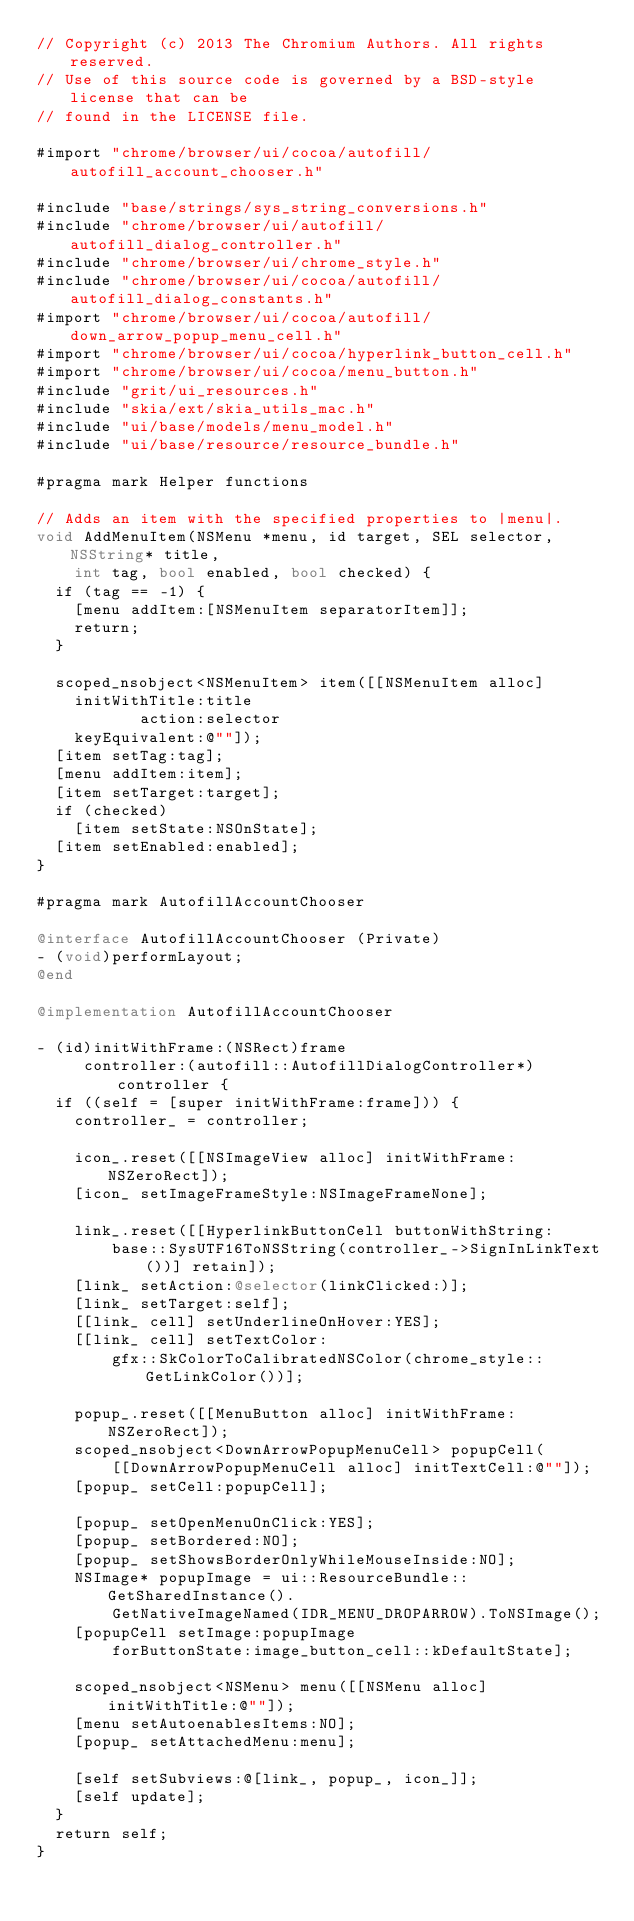<code> <loc_0><loc_0><loc_500><loc_500><_ObjectiveC_>// Copyright (c) 2013 The Chromium Authors. All rights reserved.
// Use of this source code is governed by a BSD-style license that can be
// found in the LICENSE file.

#import "chrome/browser/ui/cocoa/autofill/autofill_account_chooser.h"

#include "base/strings/sys_string_conversions.h"
#include "chrome/browser/ui/autofill/autofill_dialog_controller.h"
#include "chrome/browser/ui/chrome_style.h"
#include "chrome/browser/ui/cocoa/autofill/autofill_dialog_constants.h"
#import "chrome/browser/ui/cocoa/autofill/down_arrow_popup_menu_cell.h"
#import "chrome/browser/ui/cocoa/hyperlink_button_cell.h"
#import "chrome/browser/ui/cocoa/menu_button.h"
#include "grit/ui_resources.h"
#include "skia/ext/skia_utils_mac.h"
#include "ui/base/models/menu_model.h"
#include "ui/base/resource/resource_bundle.h"

#pragma mark Helper functions

// Adds an item with the specified properties to |menu|.
void AddMenuItem(NSMenu *menu, id target, SEL selector, NSString* title,
    int tag, bool enabled, bool checked) {
  if (tag == -1) {
    [menu addItem:[NSMenuItem separatorItem]];
    return;
  }

  scoped_nsobject<NSMenuItem> item([[NSMenuItem alloc]
    initWithTitle:title
           action:selector
    keyEquivalent:@""]);
  [item setTag:tag];
  [menu addItem:item];
  [item setTarget:target];
  if (checked)
    [item setState:NSOnState];
  [item setEnabled:enabled];
}

#pragma mark AutofillAccountChooser

@interface AutofillAccountChooser (Private)
- (void)performLayout;
@end

@implementation AutofillAccountChooser

- (id)initWithFrame:(NSRect)frame
     controller:(autofill::AutofillDialogController*)controller {
  if ((self = [super initWithFrame:frame])) {
    controller_ = controller;

    icon_.reset([[NSImageView alloc] initWithFrame:NSZeroRect]);
    [icon_ setImageFrameStyle:NSImageFrameNone];

    link_.reset([[HyperlinkButtonCell buttonWithString:
        base::SysUTF16ToNSString(controller_->SignInLinkText())] retain]);
    [link_ setAction:@selector(linkClicked:)];
    [link_ setTarget:self];
    [[link_ cell] setUnderlineOnHover:YES];
    [[link_ cell] setTextColor:
        gfx::SkColorToCalibratedNSColor(chrome_style::GetLinkColor())];

    popup_.reset([[MenuButton alloc] initWithFrame:NSZeroRect]);
    scoped_nsobject<DownArrowPopupMenuCell> popupCell(
        [[DownArrowPopupMenuCell alloc] initTextCell:@""]);
    [popup_ setCell:popupCell];

    [popup_ setOpenMenuOnClick:YES];
    [popup_ setBordered:NO];
    [popup_ setShowsBorderOnlyWhileMouseInside:NO];
    NSImage* popupImage = ui::ResourceBundle::GetSharedInstance().
        GetNativeImageNamed(IDR_MENU_DROPARROW).ToNSImage();
    [popupCell setImage:popupImage
        forButtonState:image_button_cell::kDefaultState];

    scoped_nsobject<NSMenu> menu([[NSMenu alloc] initWithTitle:@""]);
    [menu setAutoenablesItems:NO];
    [popup_ setAttachedMenu:menu];

    [self setSubviews:@[link_, popup_, icon_]];
    [self update];
  }
  return self;
}
</code> 